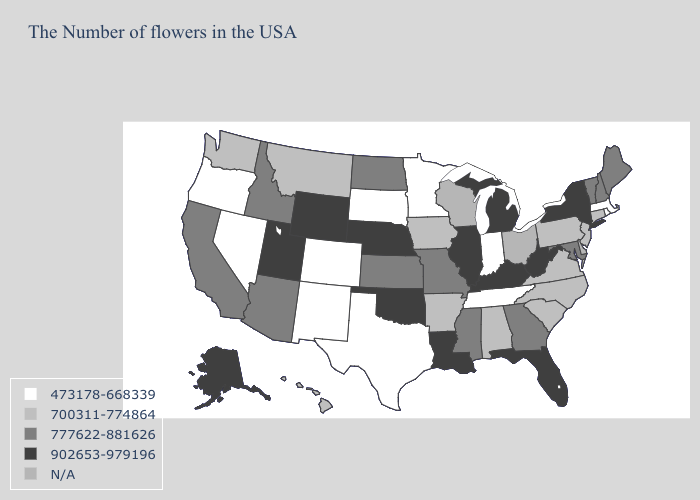What is the value of Mississippi?
Give a very brief answer. 777622-881626. Name the states that have a value in the range 473178-668339?
Give a very brief answer. Massachusetts, Rhode Island, Indiana, Tennessee, Minnesota, Texas, South Dakota, Colorado, New Mexico, Nevada, Oregon. Does Utah have the highest value in the West?
Write a very short answer. Yes. What is the value of Idaho?
Short answer required. 777622-881626. Which states hav the highest value in the South?
Short answer required. West Virginia, Florida, Kentucky, Louisiana, Oklahoma. What is the value of North Dakota?
Write a very short answer. 777622-881626. Name the states that have a value in the range 777622-881626?
Keep it brief. Maine, New Hampshire, Vermont, Maryland, Georgia, Mississippi, Missouri, Kansas, North Dakota, Arizona, Idaho, California. What is the value of West Virginia?
Answer briefly. 902653-979196. Name the states that have a value in the range N/A?
Quick response, please. Delaware, Ohio, Wisconsin. What is the value of Wisconsin?
Answer briefly. N/A. Which states have the highest value in the USA?
Write a very short answer. New York, West Virginia, Florida, Michigan, Kentucky, Illinois, Louisiana, Nebraska, Oklahoma, Wyoming, Utah, Alaska. Name the states that have a value in the range 473178-668339?
Short answer required. Massachusetts, Rhode Island, Indiana, Tennessee, Minnesota, Texas, South Dakota, Colorado, New Mexico, Nevada, Oregon. How many symbols are there in the legend?
Write a very short answer. 5. 